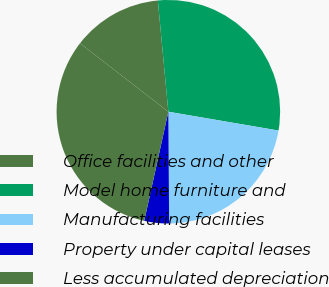<chart> <loc_0><loc_0><loc_500><loc_500><pie_chart><fcel>Office facilities and other<fcel>Model home furniture and<fcel>Manufacturing facilities<fcel>Property under capital leases<fcel>Less accumulated depreciation<nl><fcel>13.01%<fcel>29.19%<fcel>22.2%<fcel>3.57%<fcel>32.03%<nl></chart> 